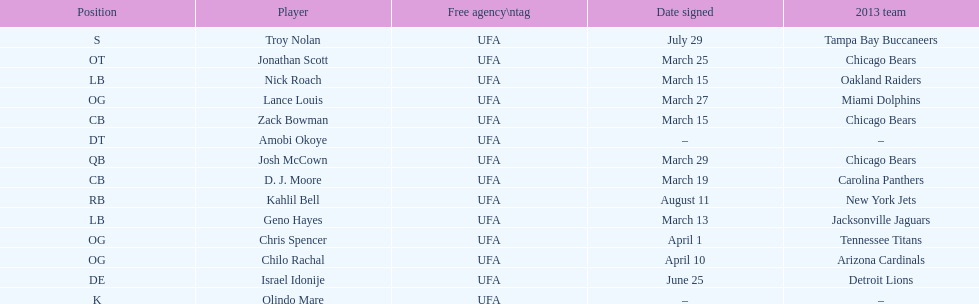The top played position according to this chart. OG. Would you be able to parse every entry in this table? {'header': ['Position', 'Player', 'Free agency\\ntag', 'Date signed', '2013 team'], 'rows': [['S', 'Troy Nolan', 'UFA', 'July 29', 'Tampa Bay Buccaneers'], ['OT', 'Jonathan Scott', 'UFA', 'March 25', 'Chicago Bears'], ['LB', 'Nick Roach', 'UFA', 'March 15', 'Oakland Raiders'], ['OG', 'Lance Louis', 'UFA', 'March 27', 'Miami Dolphins'], ['CB', 'Zack Bowman', 'UFA', 'March 15', 'Chicago Bears'], ['DT', 'Amobi Okoye', 'UFA', '–', '–'], ['QB', 'Josh McCown', 'UFA', 'March 29', 'Chicago Bears'], ['CB', 'D. J. Moore', 'UFA', 'March 19', 'Carolina Panthers'], ['RB', 'Kahlil Bell', 'UFA', 'August 11', 'New York Jets'], ['LB', 'Geno Hayes', 'UFA', 'March 13', 'Jacksonville Jaguars'], ['OG', 'Chris Spencer', 'UFA', 'April 1', 'Tennessee Titans'], ['OG', 'Chilo Rachal', 'UFA', 'April 10', 'Arizona Cardinals'], ['DE', 'Israel Idonije', 'UFA', 'June 25', 'Detroit Lions'], ['K', 'Olindo Mare', 'UFA', '–', '–']]} 